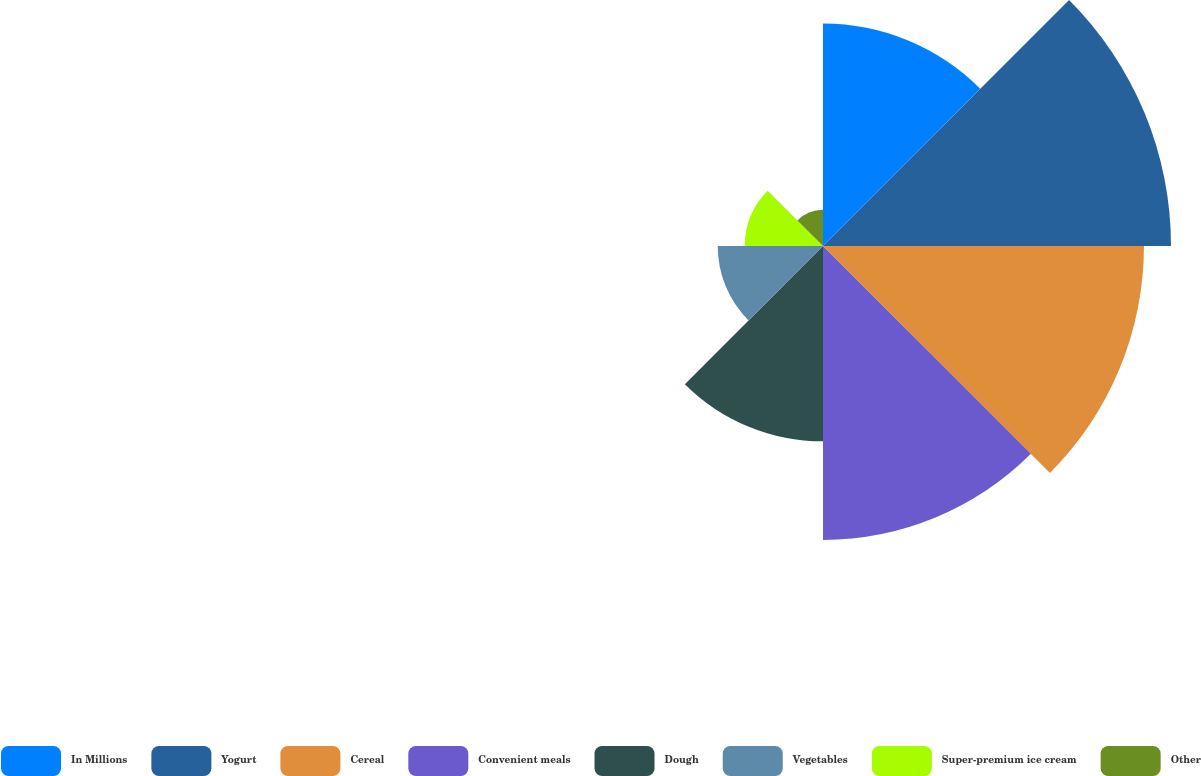Convert chart. <chart><loc_0><loc_0><loc_500><loc_500><pie_chart><fcel>In Millions<fcel>Yogurt<fcel>Cereal<fcel>Convenient meals<fcel>Dough<fcel>Vegetables<fcel>Super-premium ice cream<fcel>Other<nl><fcel>13.9%<fcel>21.75%<fcel>20.06%<fcel>18.37%<fcel>12.21%<fcel>6.58%<fcel>4.89%<fcel>2.26%<nl></chart> 